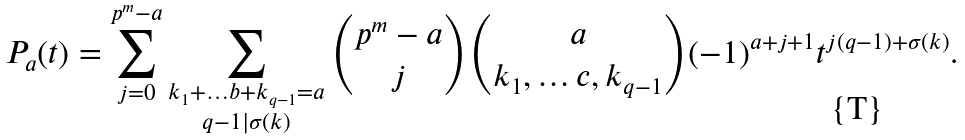Convert formula to latex. <formula><loc_0><loc_0><loc_500><loc_500>P _ { a } ( t ) = \sum _ { j = 0 } ^ { p ^ { m } - a } \sum _ { \substack { k _ { 1 } + \dots b + k _ { q - 1 } = a \\ q - 1 | \sigma ( k ) } } \binom { p ^ { m } - a } { j } \binom { a } { k _ { 1 } , \dots c , k _ { q - 1 } } ( - 1 ) ^ { a + j + 1 } t ^ { j ( q - 1 ) + \sigma ( k ) } .</formula> 